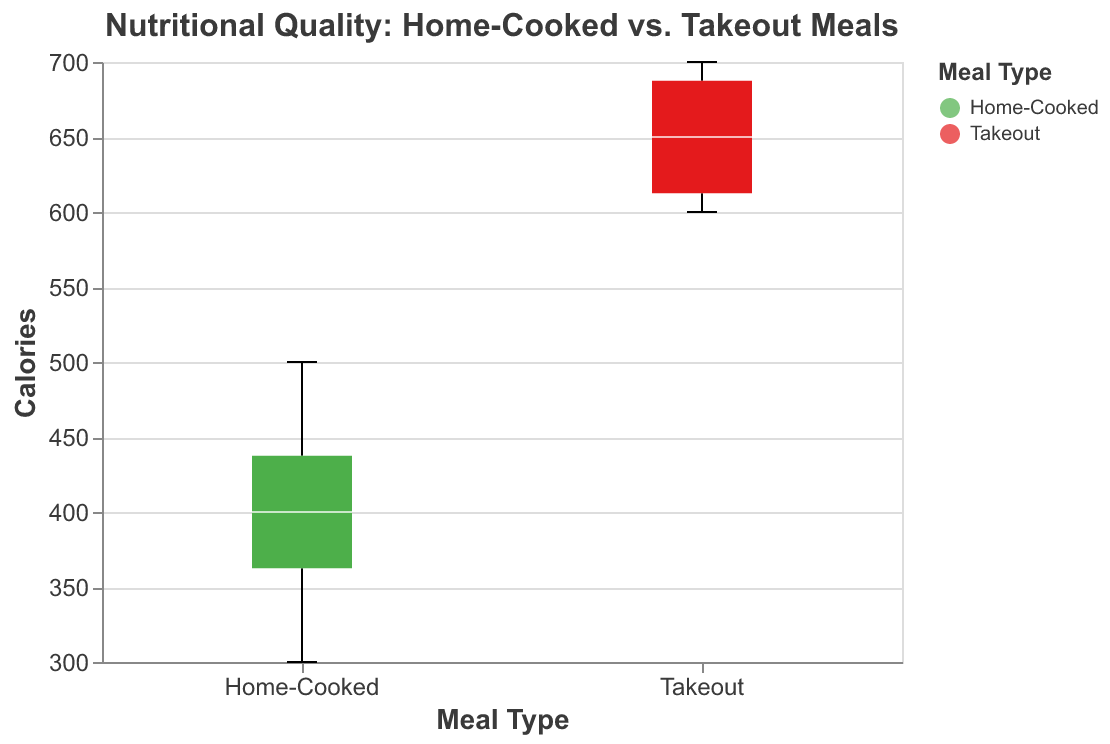What's the title of the figure? The title is usually displayed at the top of the figure. In this figure, it's "Nutritional Quality: Home-Cooked vs. Takeout Meals".
Answer: Nutritional Quality: Home-Cooked vs. Takeout Meals Which colors represent Home-Cooked and Takeout meals? The two different types of meals are represented by different colors in the legend or on the box plots. In this figure, Home-Cooked meals are green and Takeout meals are red.
Answer: Home-Cooked: green, Takeout: red Which meal type generally has higher calorie content? By comparing the median lines of the box plots for both meal types, you can determine which has a higher calorie content. The median line in the red box plot (Takeout) is higher than the green box plot (Home-Cooked).
Answer: Takeout meals What is the median calorie value for Home-Cooked meals? The median value is indicated by the white line inside the box plot for Home-Cooked meals.
Answer: 400 calories What is the calorie range for Takeout meals? The range of calories for each meal type can be determined by looking at the minimum and maximum points of the box plot for Takeout meals.
Answer: 600-700 calories By how much is the median calorie content different between Home-Cooked and Takeout meals? Subtract the median calorie value of Home-Cooked meals from the median calorie value of Takeout meals. 650 (Takeout) - 400 (Home-Cooked) = 250.
Answer: 250 calories Which meal type has a wider interquartile range (IQR) for calorie content? The IQR is the difference between the 75th percentile (top edge of the box) and the 25th percentile (bottom edge of the box). Compare the width of the boxes.
Answer: Home-Cooked meals Are there any outliers in the calorie content for either meal type? Outliers are shown as points outside the whiskers of the box plot. There are no points outside the whiskers in the box plots for both meal types in this figure.
Answer: No outliers What can you infer about the nutritional quality (in terms of calories) of home-cooked meals vs. takeout meals based on this figure? By analyzing the median, range, and overall distribution shown in the box plots, it is evident that Home-Cooked meals generally have lower calorie content and less variation, while Takeout meals have higher calorie content and a tighter range.
Answer: Home-Cooked meals generally have lower calories and less variation compared to Takeout meals 